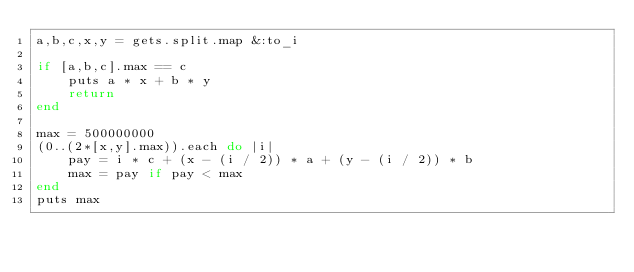<code> <loc_0><loc_0><loc_500><loc_500><_Ruby_>a,b,c,x,y = gets.split.map &:to_i
 
if [a,b,c].max == c
    puts a * x + b * y
    return
end
 
max = 500000000
(0..(2*[x,y].max)).each do |i|
    pay = i * c + (x - (i / 2)) * a + (y - (i / 2)) * b
    max = pay if pay < max
end
puts max</code> 